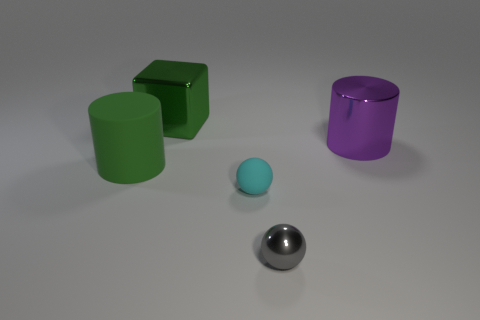Add 2 tiny brown rubber objects. How many objects exist? 7 Add 1 small brown cubes. How many small brown cubes exist? 1 Subtract 0 blue spheres. How many objects are left? 5 Subtract all balls. How many objects are left? 3 Subtract all large yellow metallic spheres. Subtract all big purple cylinders. How many objects are left? 4 Add 5 green rubber cylinders. How many green rubber cylinders are left? 6 